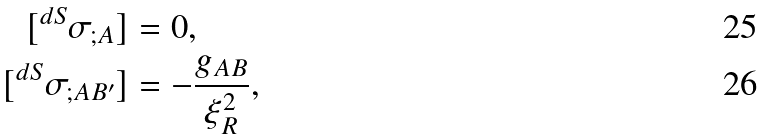Convert formula to latex. <formula><loc_0><loc_0><loc_500><loc_500>[ ^ { d S } \sigma _ { ; A } ] & = 0 , \\ { [ ^ { d S } \sigma _ { ; A B ^ { \prime } } ] } & = - \frac { g _ { A B } } { \xi _ { R } ^ { 2 } } ,</formula> 